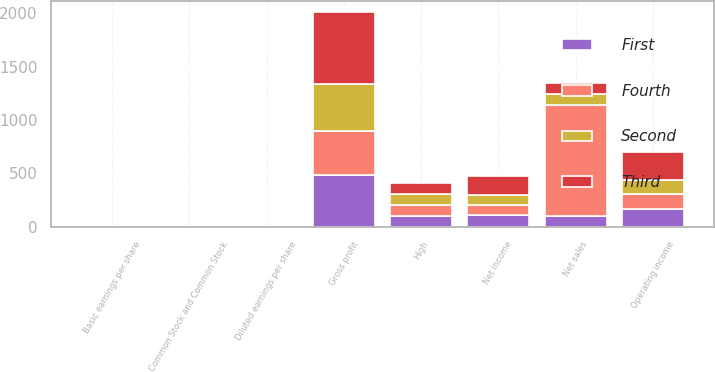<chart> <loc_0><loc_0><loc_500><loc_500><stacked_bar_chart><ecel><fcel>Net sales<fcel>Gross profit<fcel>Operating income<fcel>Net income<fcel>Basic earnings per share<fcel>Diluted earnings per share<fcel>Common Stock and Common Stock<fcel>High<nl><fcel>Fourth<fcel>1043.7<fcel>413<fcel>134.2<fcel>93.5<fcel>0.75<fcel>0.74<fcel>0.47<fcel>98.9<nl><fcel>Second<fcel>100<fcel>444.6<fcel>132.6<fcel>100<fcel>0.8<fcel>0.79<fcel>0.47<fcel>104.26<nl><fcel>First<fcel>100<fcel>484.4<fcel>168.7<fcel>108.2<fcel>0.86<fcel>0.85<fcel>0.47<fcel>105.64<nl><fcel>Third<fcel>100<fcel>668.2<fcel>266.9<fcel>175.7<fcel>1.34<fcel>1.32<fcel>0.47<fcel>102.72<nl></chart> 